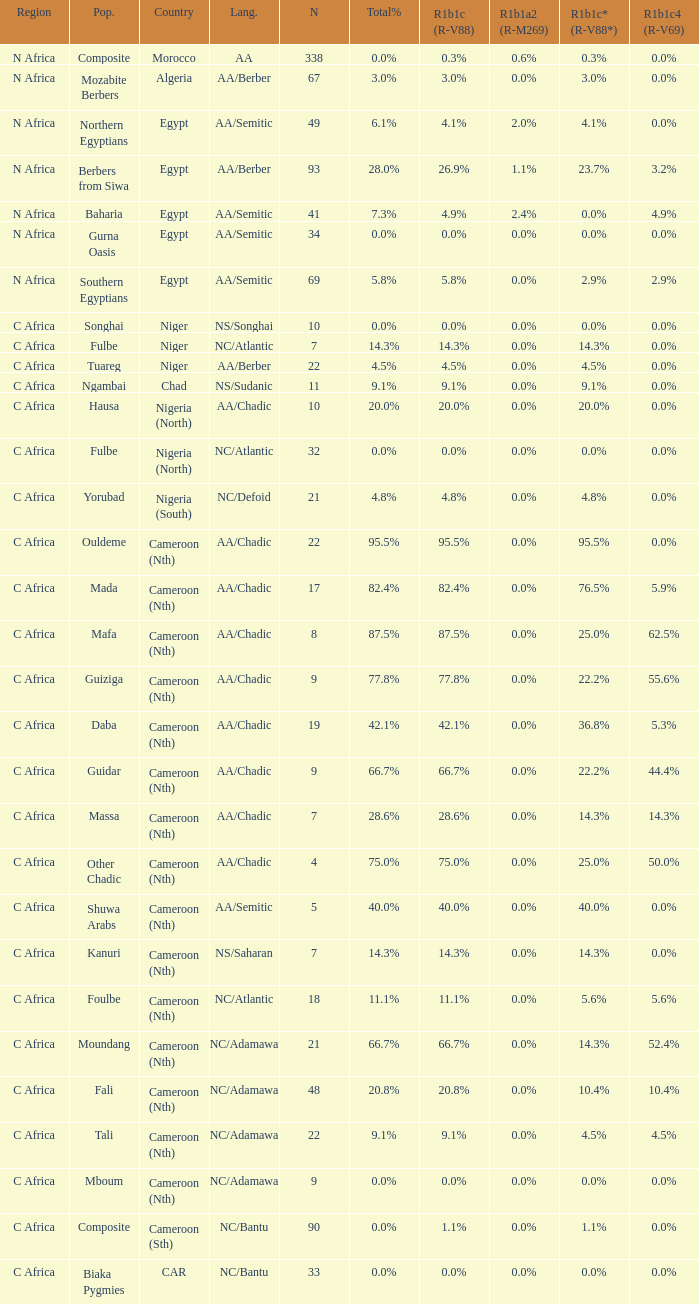How many n are listed for 0.6% r1b1a2 (r-m269)? 1.0. 